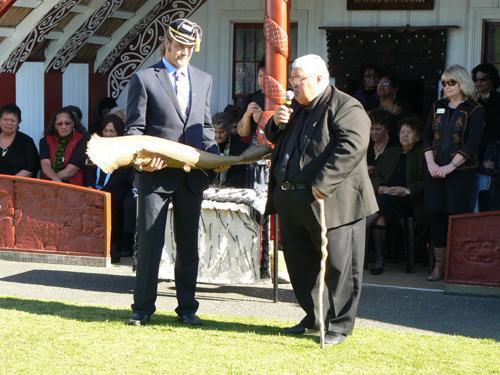How many dogs are in this photo?
Give a very brief answer. 0. How many people are there?
Give a very brief answer. 8. How many zebras are pictured?
Give a very brief answer. 0. 